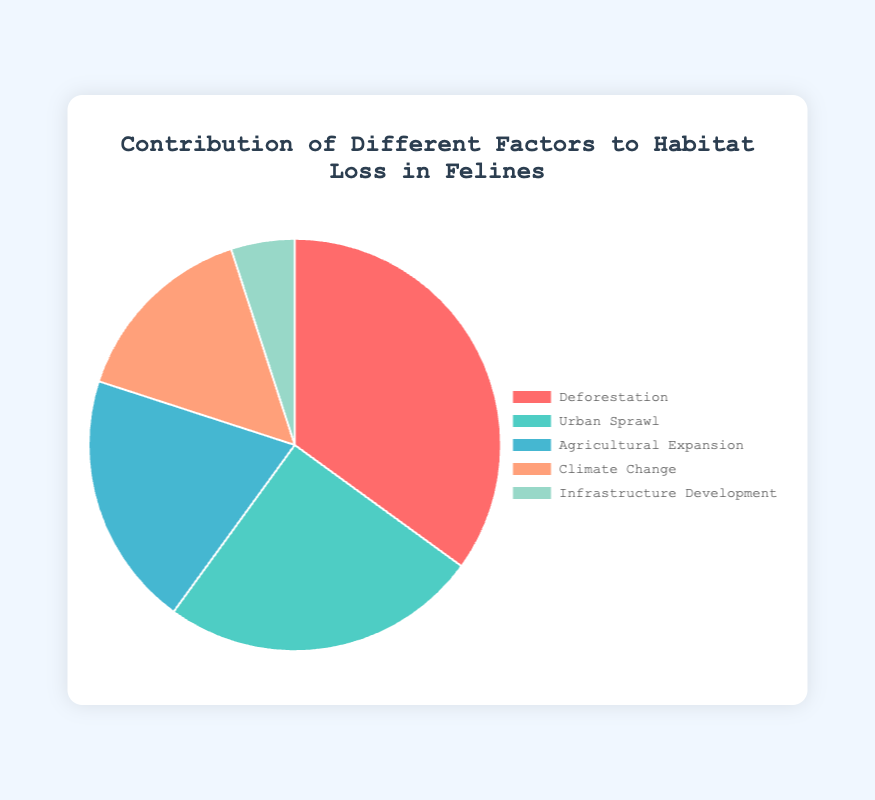What is the largest factor contributing to habitat loss in felines? The largest section in the pie chart corresponds to "Deforestation," which occupies 35% of the total contribution.
Answer: Deforestation Which factor contributes the least to habitat loss in felines? The smallest section in the pie chart corresponds to "Infrastructure Development," which occupies 5% of the total contribution.
Answer: Infrastructure Development How much more does deforestation contribute to habitat loss compared to agricultural expansion? According to the pie chart, deforestation contributes 35%, while agricultural expansion contributes 20%. The difference is 35% - 20% = 15%.
Answer: 15% What is the combined contribution of urban sprawl and climate change to habitat loss? Urban sprawl contributes 25% and climate change 15%. The combined contribution is 25% + 15% = 40%.
Answer: 40% Which factor contributes more, climate change or urban sprawl, and by how much? The pie chart shows that urban sprawl contributes 25%, while climate change contributes 15%. Urban sprawl contributes 25% - 15% = 10% more.
Answer: Urban Sprawl by 10% Is the contribution of infrastructure development greater or less than half of the contribution of agricultural expansion? Infrastructure development contributes 5%, and agricultural expansion contributes 20%. Half of agricultural expansion's contribution is 20% / 2 = 10%. Since 5% < 10%, infrastructure development contributes less than half.
Answer: Less What is the average contribution of all the factors to habitat loss? Sum of percentages: 35% (Deforestation) + 25% (Urban Sprawl) + 20% (Agricultural Expansion) + 15% (Climate Change) + 5% (Infrastructure Development) = 100%. Number of factors = 5. So, the average contribution is 100% / 5 = 20%.
Answer: 20% How much more does urban sprawl contribute compared to infrastructure development? Urban sprawl contributes 25% while infrastructure development contributes 5%. The difference is 25% - 5% = 20%.
Answer: 20% Identify the factor labeled with a pale blue color and its contribution percentage. The pale blue color corresponds to "Agricultural Expansion," which contributes 20%.
Answer: Agricultural Expansion, 20% Which factor has a contribution that is closest to the median value of all contributions? Listing contributions: 35%, 25%, 20%, 15%, 5%. The median of these sorted values is 20%. "Agricultural Expansion" corresponds to this value.
Answer: Agricultural Expansion 